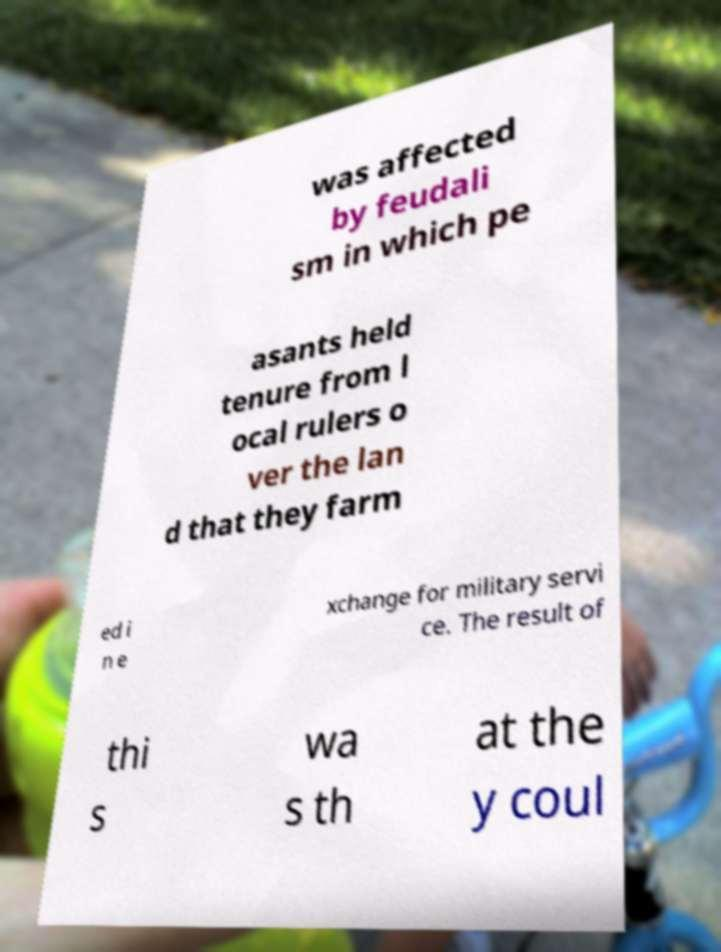Could you extract and type out the text from this image? was affected by feudali sm in which pe asants held tenure from l ocal rulers o ver the lan d that they farm ed i n e xchange for military servi ce. The result of thi s wa s th at the y coul 